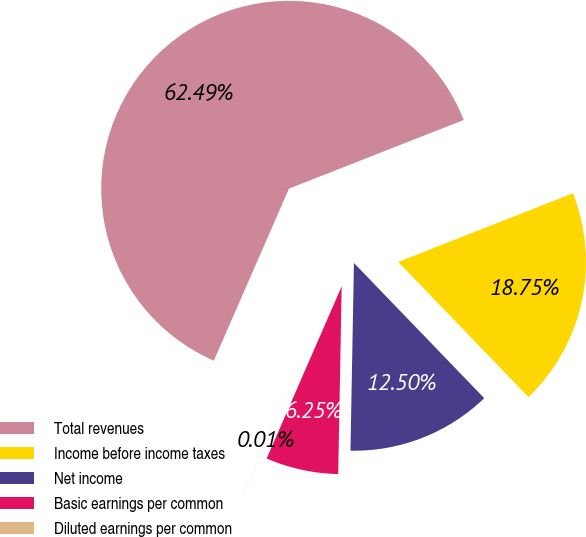<chart> <loc_0><loc_0><loc_500><loc_500><pie_chart><fcel>Total revenues<fcel>Income before income taxes<fcel>Net income<fcel>Basic earnings per common<fcel>Diluted earnings per common<nl><fcel>62.49%<fcel>18.75%<fcel>12.5%<fcel>6.25%<fcel>0.01%<nl></chart> 